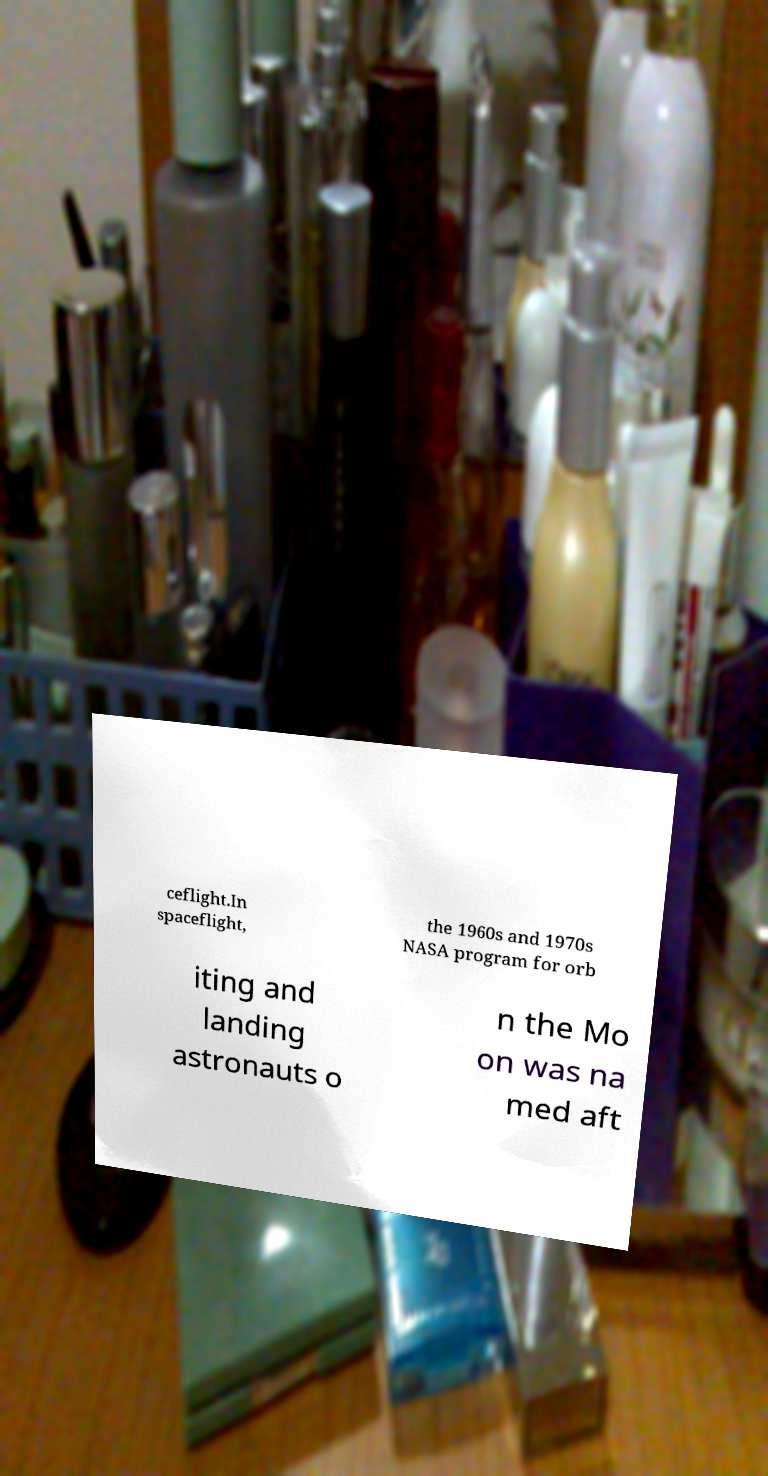Can you read and provide the text displayed in the image?This photo seems to have some interesting text. Can you extract and type it out for me? ceflight.In spaceflight, the 1960s and 1970s NASA program for orb iting and landing astronauts o n the Mo on was na med aft 